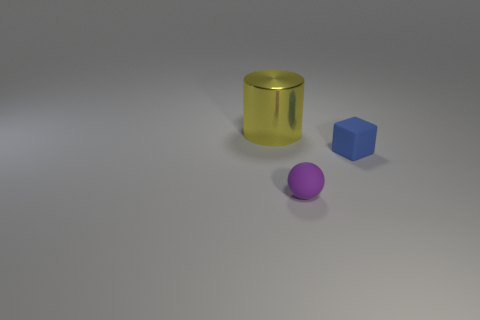Is there any other thing that is made of the same material as the cylinder?
Provide a short and direct response. No. There is a object that is both behind the tiny purple rubber sphere and on the left side of the small blue rubber object; what is its size?
Your response must be concise. Large. Is the number of blue objects that are in front of the tiny rubber block greater than the number of large yellow metallic objects that are right of the cylinder?
Offer a terse response. No. What is the color of the big thing?
Offer a very short reply. Yellow. What is the color of the object that is behind the tiny ball and left of the blue cube?
Provide a short and direct response. Yellow. The tiny object that is on the right side of the tiny thing that is in front of the small block that is behind the sphere is what color?
Your answer should be compact. Blue. What color is the object that is the same size as the blue cube?
Provide a succinct answer. Purple. What shape is the object right of the small rubber thing left of the small object that is right of the purple object?
Ensure brevity in your answer.  Cube. How many things are metal objects or objects in front of the yellow metal cylinder?
Your response must be concise. 3. Is the size of the thing on the right side of the matte ball the same as the yellow cylinder?
Your response must be concise. No. 